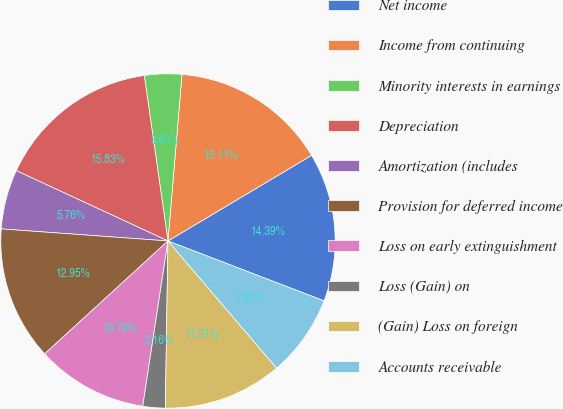Convert chart to OTSL. <chart><loc_0><loc_0><loc_500><loc_500><pie_chart><fcel>Net income<fcel>Income from continuing<fcel>Minority interests in earnings<fcel>Depreciation<fcel>Amortization (includes<fcel>Provision for deferred income<fcel>Loss on early extinguishment<fcel>Loss (Gain) on<fcel>(Gain) Loss on foreign<fcel>Accounts receivable<nl><fcel>14.39%<fcel>15.11%<fcel>3.6%<fcel>15.83%<fcel>5.76%<fcel>12.95%<fcel>10.79%<fcel>2.16%<fcel>11.51%<fcel>7.91%<nl></chart> 